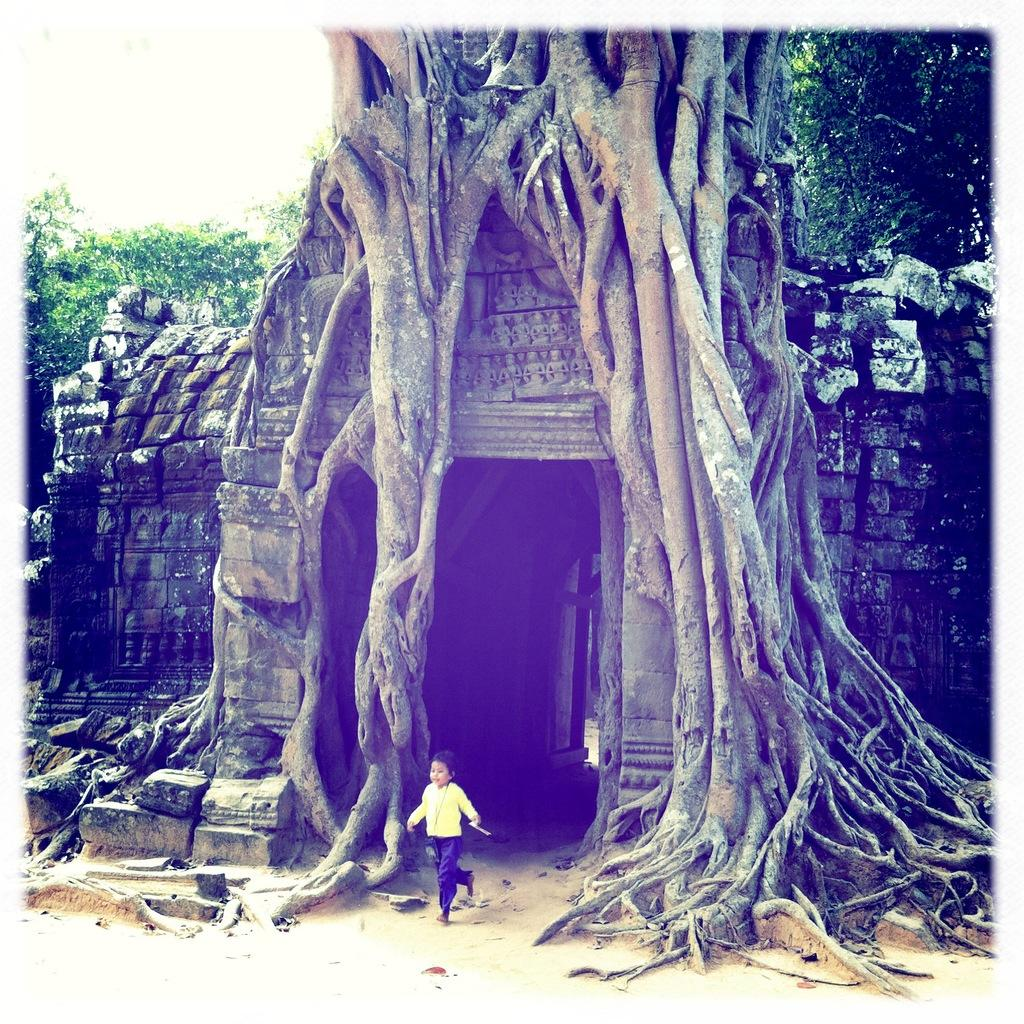What is the child in the image doing? The child is running on the ground in the image. What can be seen in the background of the image? There are trees and buildings visible in the image. What is visible in the sky in the image? The sky is visible in the background of the image. What type of eggnog is the child drinking in the image? There is no eggnog present in the image; the child is running on the ground. What type of shoes is the child wearing while running in the image? The image does not show the child's shoes, so it cannot be determined from the image. 